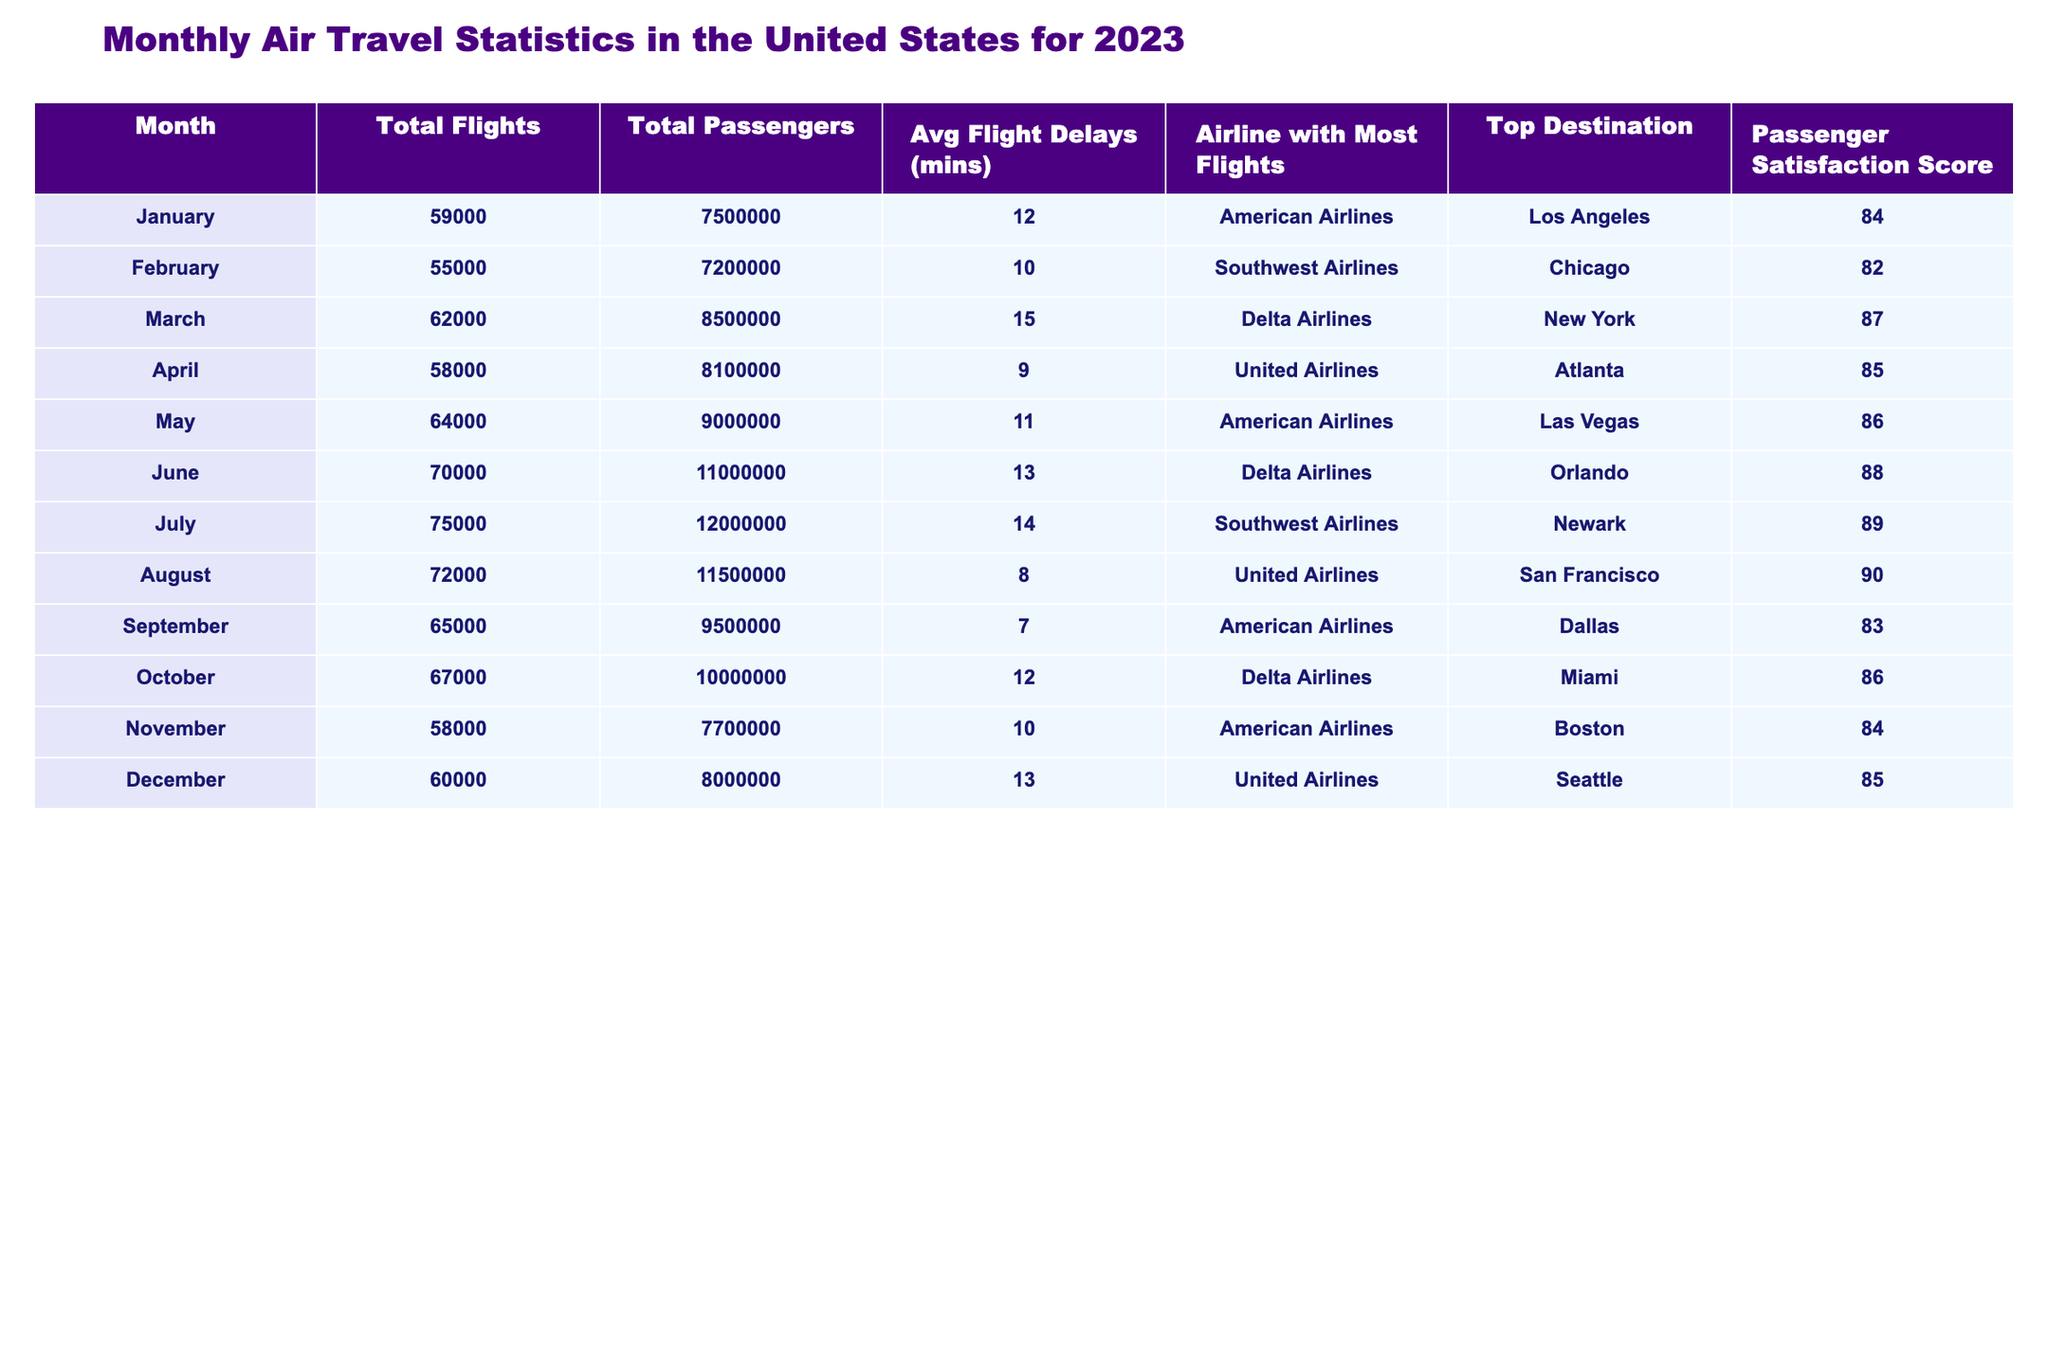What month had the highest number of total passengers? By reviewing the 'Total Passengers' column, the month with the highest number is July with 12,000,000 passengers.
Answer: July Which airline had the most flights in March? The 'Airline with Most Flights' for March is Delta Airlines, as listed in the corresponding row.
Answer: Delta Airlines What was the average flight delay in August? The table indicates that the Avg Flight Delays in August is 8 minutes, as shown in the respective row.
Answer: 8 minutes Which month had the lowest passenger satisfaction score? The lowest Passenger Satisfaction Score is in February, at 82. This can be found in the table row for February.
Answer: February What is the total number of flights from June to August? Summing the total flights from June (70,000), July (75,000), and August (72,000) gives 70,000 + 75,000 + 72,000 = 217,000 flights.
Answer: 217,000 flights Did the average flight delay in November exceed 11 minutes? The average flight delay in November is 10 minutes, which does not exceed 11 minutes; this can be confirmed by checking the Avg Flight Delays column.
Answer: No Which month recorded the highest average flight delay? Comparing the Avg Flight Delays, March recorded the highest at 15 minutes, making it the month with the greatest delay.
Answer: March How many total passengers flew in the first half of the year (January to June)? The total passengers for the first half are: January (7,500,000) + February (7,200,000) + March (8,500,000) + April (8,100,000) + May (9,000,000) + June (11,000,000) = 51,300,000 passengers.
Answer: 51,300,000 passengers What was the top destination in October? The top destination in October is Miami, according to the relevant row in the table.
Answer: Miami Which two months had the same airline with the most flights? Both January and May have American Airlines as the airline with the most flights. This can be seen by comparing the respective rows.
Answer: January and May 